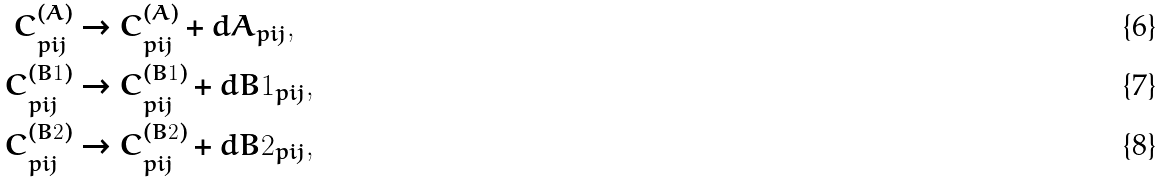Convert formula to latex. <formula><loc_0><loc_0><loc_500><loc_500>C _ { p i j } ^ { ( A ) } & \rightarrow C _ { p i j } ^ { ( A ) } + d A _ { p i j } , \\ C _ { p i j } ^ { ( B 1 ) } & \rightarrow C _ { p i j } ^ { ( B 1 ) } + d B 1 _ { p i j } , \\ C _ { p i j } ^ { ( B 2 ) } & \rightarrow C _ { p i j } ^ { ( B 2 ) } + d B 2 _ { p i j } ,</formula> 